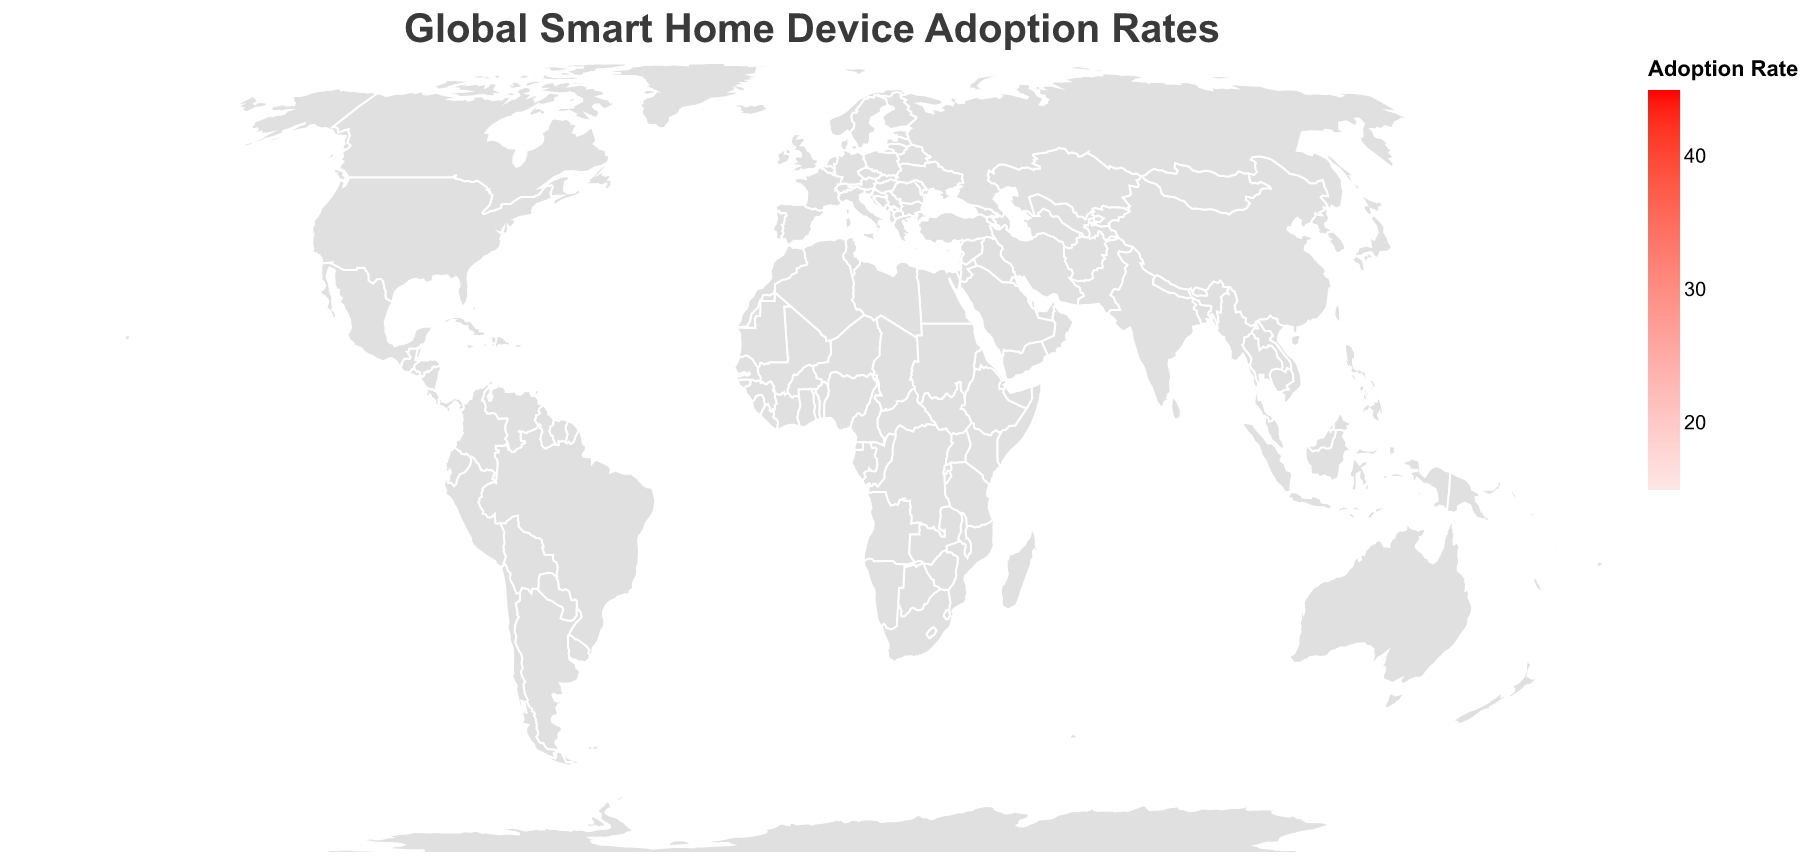What's the highest adoption rate shown in the plot? The highest adoption rate is identifiable by finding the country with the darkest shade of red. The country is the United States, with an adoption rate marked on the plot.
Answer: 42.5% Which country has the lowest adoption rate? The country with the lowest adoption rate can be identified by finding the country with the lightest shade of red. From the data, we see that Indonesia holds this rate, confirmed visually on the map.
Answer: Indonesia How does South Korea's adoption rate compare to Japan's? Locate both South Korea and Japan on the map and observe their shades of red. Comparing these, South Korea is slightly darker, indicating a higher rate slightly above Japan's. From the data, South Korea is at 37.9%, and Japan is at 32.6%.
Answer: South Korea has a higher rate What is the average adoption rate of the top 5 countries? Look at the adoption rates for the top 5 countries: United States (42.5), China (38.7), South Korea (37.9), Germany (34.2), and United Kingdom (33.8). Summing these gives 187.1, and dividing by 5 gives the average.
Answer: 37.4% Which country in Europe has the highest adoption rate? Identify European countries on the map and compare their shades of red. Visually, Germany appears the darkest among European nations, and the data confirms it at 34.2%.
Answer: Germany What is the range of adoption rates across all shown countries? The range is found by subtracting the smallest value (Indonesia at 16.4%) from the largest value (United States at 42.5%). The difference reflects the total spread of adoption rates.
Answer: 26.1% How many countries have an adoption rate above 30%? Identify and count the countries that fall in the darker shades of red. From the data: United States, China, South Korea, Germany, United Kingdom, Japan, Australia, and Canada have rates above 30%. This yields 8 countries.
Answer: 8 countries What would be the adoption rate for a country positioned in the middle of the dataset? To find the median value, first order the adoption rates. With 20 data points, the median would be the average of the 10th and 11th values. From the data, these are Netherlands (28.7) and Sweden (27.9), which average to 28.3.
Answer: 28.3% What regions have noticeably lower adoption rates? Compare different regions on the map. The lighter shades of red indicate lower adoption rates. From the data, regions including Russia, Mexico, South Africa, Turkey, and Indonesia show noticeably lower rates.
Answer: Russia, Mexico, South Africa, Turkey, Indonesia 